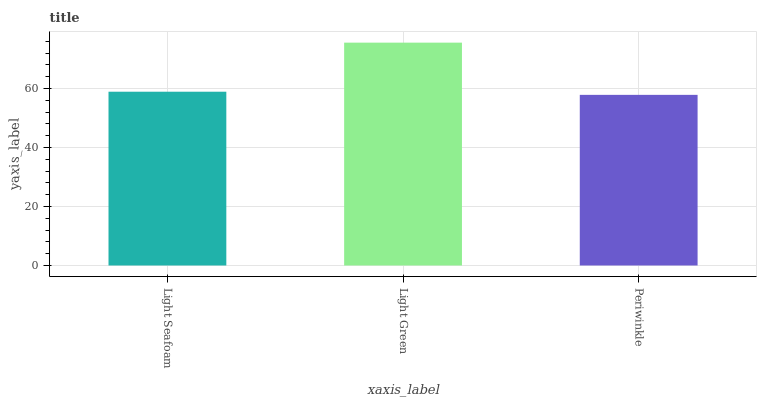Is Periwinkle the minimum?
Answer yes or no. Yes. Is Light Green the maximum?
Answer yes or no. Yes. Is Light Green the minimum?
Answer yes or no. No. Is Periwinkle the maximum?
Answer yes or no. No. Is Light Green greater than Periwinkle?
Answer yes or no. Yes. Is Periwinkle less than Light Green?
Answer yes or no. Yes. Is Periwinkle greater than Light Green?
Answer yes or no. No. Is Light Green less than Periwinkle?
Answer yes or no. No. Is Light Seafoam the high median?
Answer yes or no. Yes. Is Light Seafoam the low median?
Answer yes or no. Yes. Is Light Green the high median?
Answer yes or no. No. Is Light Green the low median?
Answer yes or no. No. 